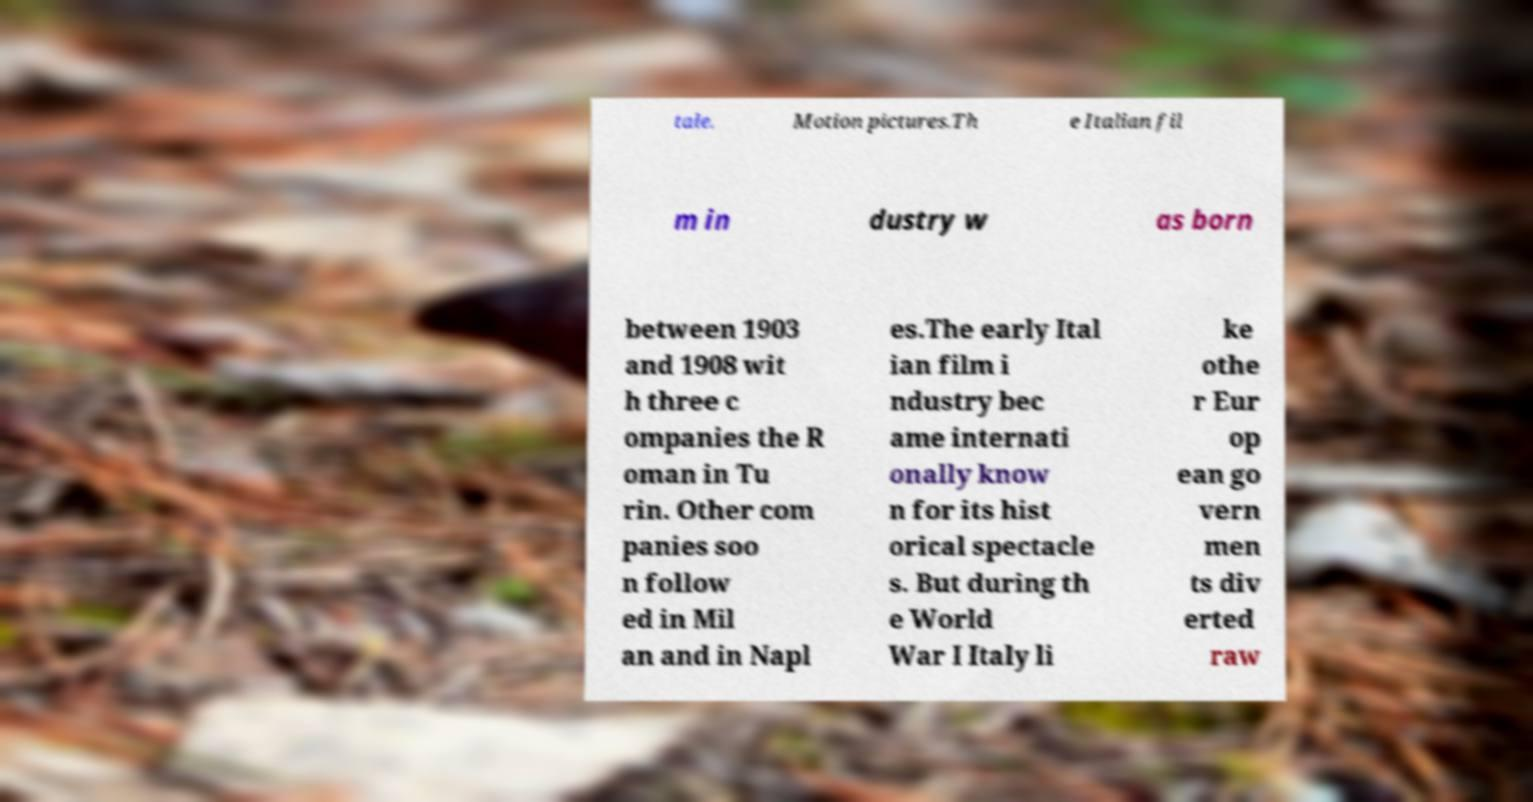Could you extract and type out the text from this image? tale. Motion pictures.Th e Italian fil m in dustry w as born between 1903 and 1908 wit h three c ompanies the R oman in Tu rin. Other com panies soo n follow ed in Mil an and in Napl es.The early Ital ian film i ndustry bec ame internati onally know n for its hist orical spectacle s. But during th e World War I Italy li ke othe r Eur op ean go vern men ts div erted raw 